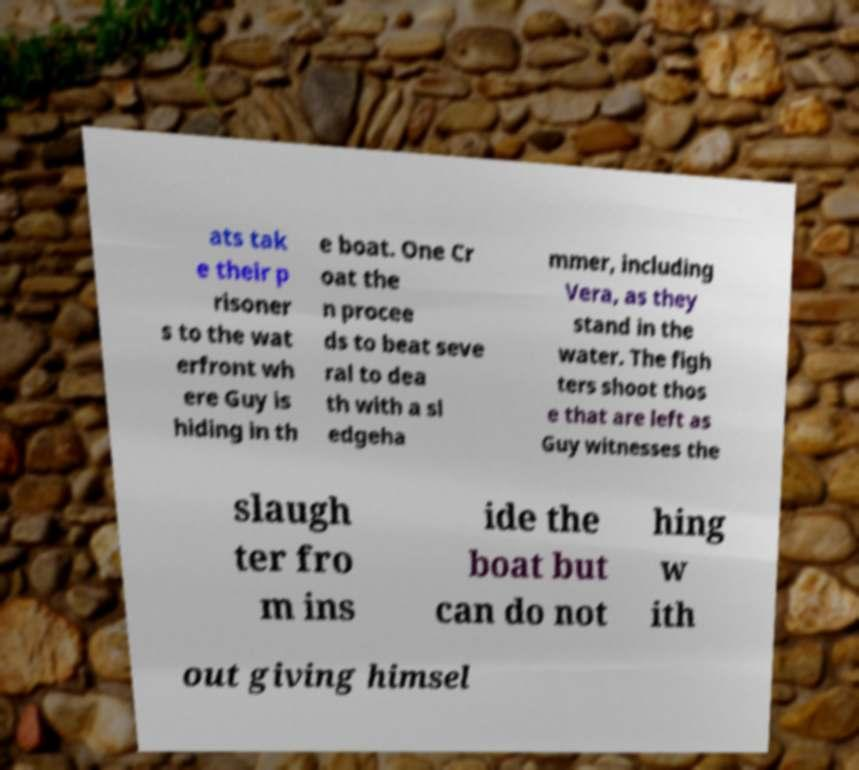What messages or text are displayed in this image? I need them in a readable, typed format. ats tak e their p risoner s to the wat erfront wh ere Guy is hiding in th e boat. One Cr oat the n procee ds to beat seve ral to dea th with a sl edgeha mmer, including Vera, as they stand in the water. The figh ters shoot thos e that are left as Guy witnesses the slaugh ter fro m ins ide the boat but can do not hing w ith out giving himsel 